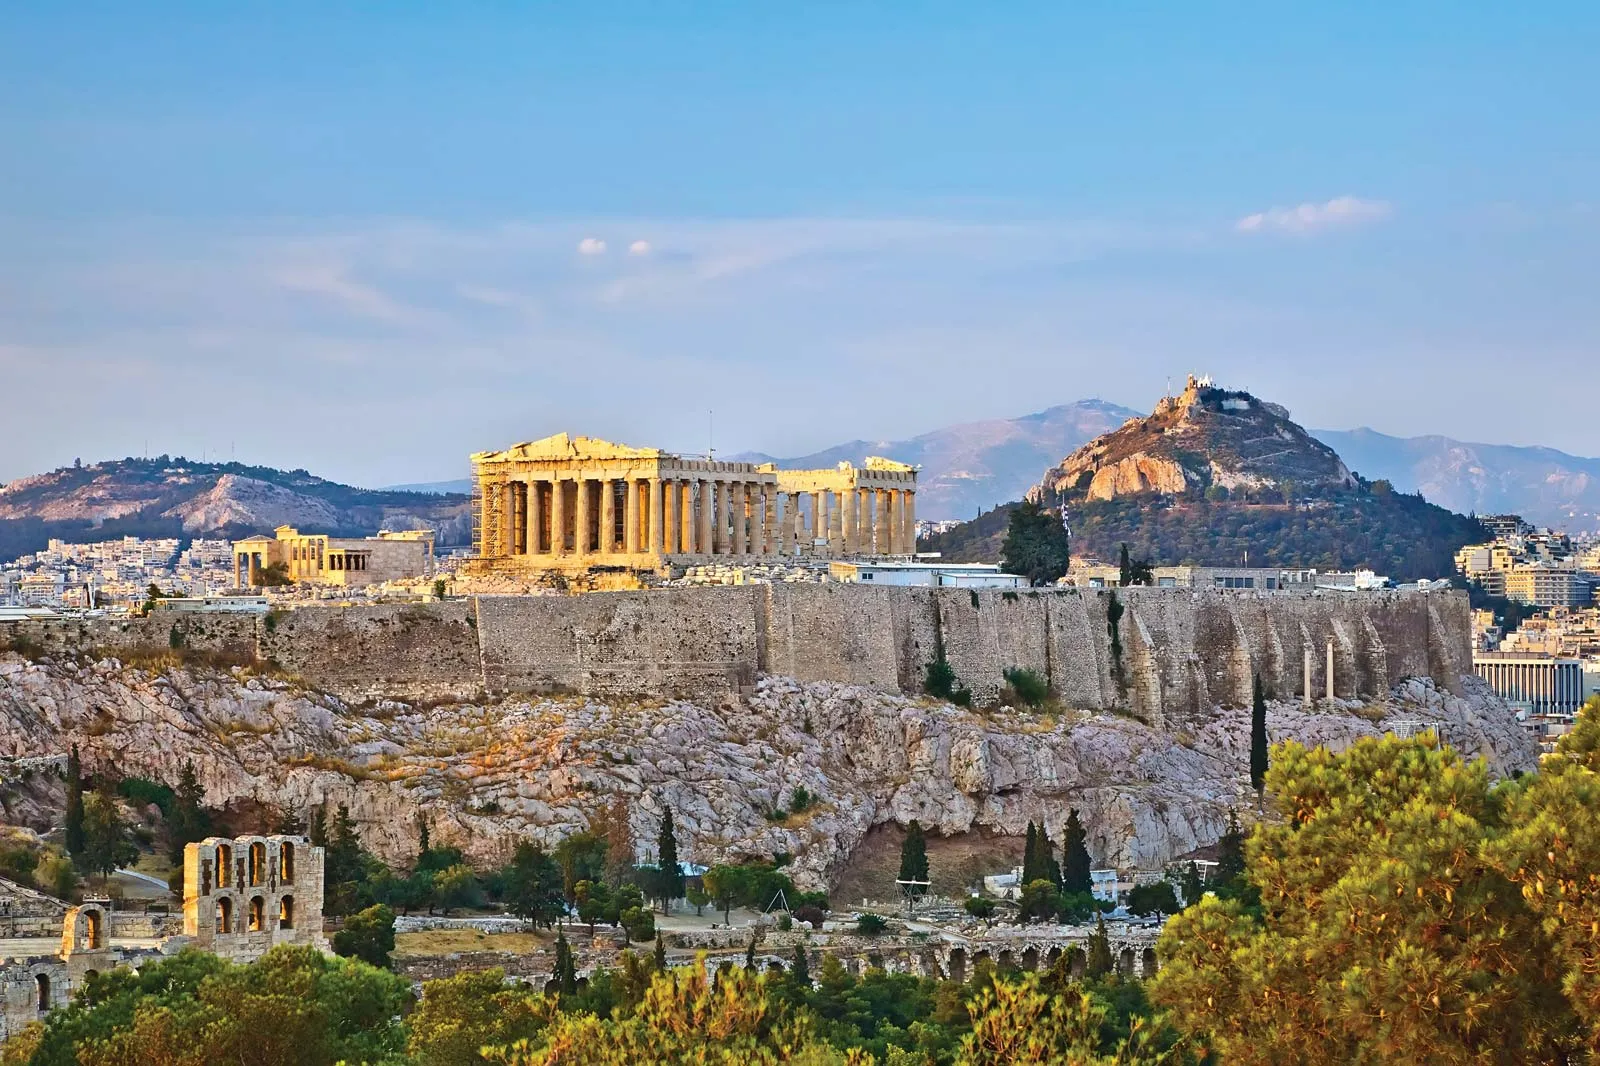What do you see happening in this image? The image captures the grandeur of the Acropolis, an ancient citadel perched on a rocky outcrop above the city of Athens, Greece. The Acropolis, bathed in warm hues, stands as a testament to the architectural prowess of the ancient Greeks. The most prominent structure visible is the Parthenon, a temple dedicated to the goddess Athena. Its white marble columns rise majestically against the clear blue sky. Surrounding the Acropolis, you can see parts of modern Athens, with its mix of contemporary and traditional architecture, creating a stark contrast with the ancient ruins. The lush greenery around the Acropolis adds a touch of nature, enhancing the visual appeal. This panoramic view offers a snapshot of both the historical and present-day essence of Athens. 